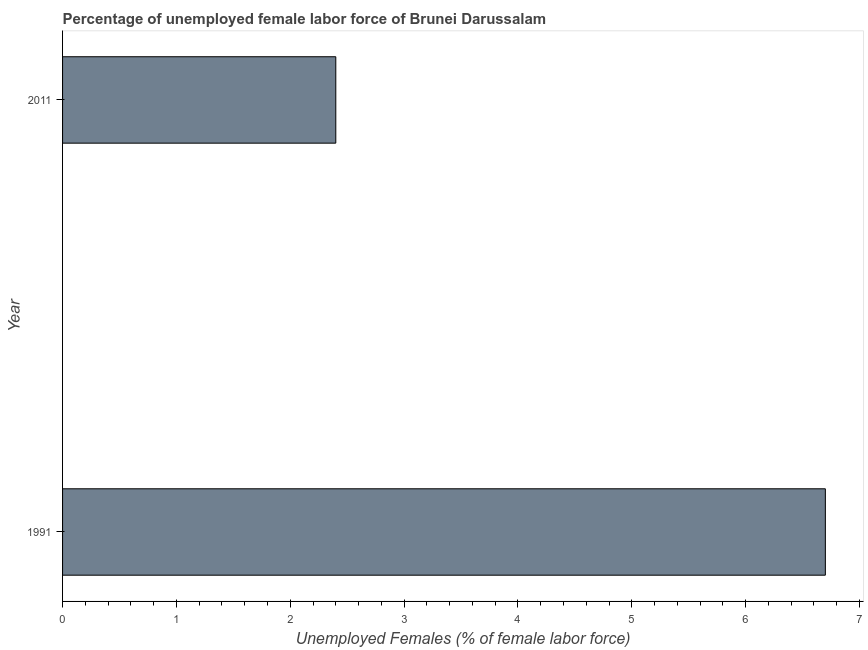Does the graph contain any zero values?
Provide a succinct answer. No. What is the title of the graph?
Provide a short and direct response. Percentage of unemployed female labor force of Brunei Darussalam. What is the label or title of the X-axis?
Your answer should be compact. Unemployed Females (% of female labor force). What is the label or title of the Y-axis?
Make the answer very short. Year. What is the total unemployed female labour force in 1991?
Provide a short and direct response. 6.7. Across all years, what is the maximum total unemployed female labour force?
Provide a succinct answer. 6.7. Across all years, what is the minimum total unemployed female labour force?
Your answer should be compact. 2.4. What is the sum of the total unemployed female labour force?
Make the answer very short. 9.1. What is the average total unemployed female labour force per year?
Your answer should be compact. 4.55. What is the median total unemployed female labour force?
Ensure brevity in your answer.  4.55. Do a majority of the years between 1991 and 2011 (inclusive) have total unemployed female labour force greater than 1.2 %?
Your response must be concise. Yes. What is the ratio of the total unemployed female labour force in 1991 to that in 2011?
Give a very brief answer. 2.79. Is the total unemployed female labour force in 1991 less than that in 2011?
Ensure brevity in your answer.  No. In how many years, is the total unemployed female labour force greater than the average total unemployed female labour force taken over all years?
Give a very brief answer. 1. How many years are there in the graph?
Provide a short and direct response. 2. What is the difference between two consecutive major ticks on the X-axis?
Make the answer very short. 1. What is the Unemployed Females (% of female labor force) in 1991?
Make the answer very short. 6.7. What is the Unemployed Females (% of female labor force) of 2011?
Provide a succinct answer. 2.4. What is the ratio of the Unemployed Females (% of female labor force) in 1991 to that in 2011?
Your answer should be very brief. 2.79. 